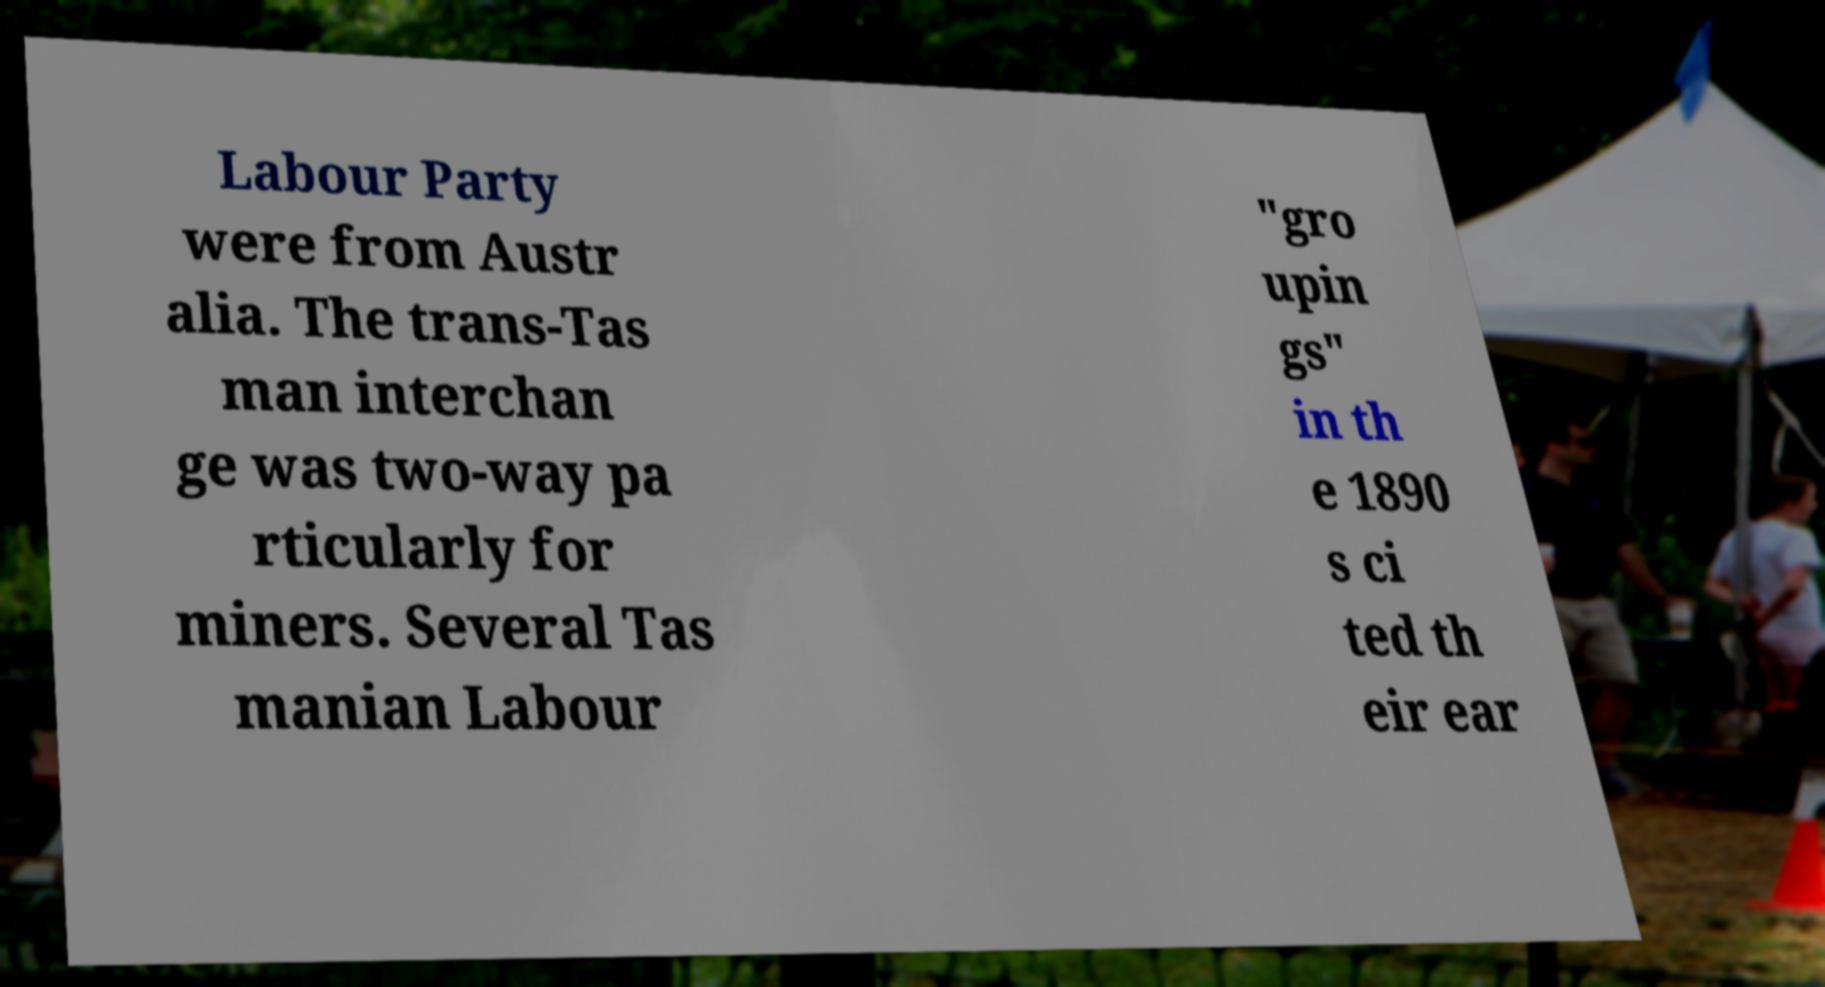Could you assist in decoding the text presented in this image and type it out clearly? Labour Party were from Austr alia. The trans-Tas man interchan ge was two-way pa rticularly for miners. Several Tas manian Labour "gro upin gs" in th e 1890 s ci ted th eir ear 